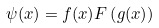Convert formula to latex. <formula><loc_0><loc_0><loc_500><loc_500>\psi ( x ) = f ( x ) F \left ( g ( x ) \right )</formula> 